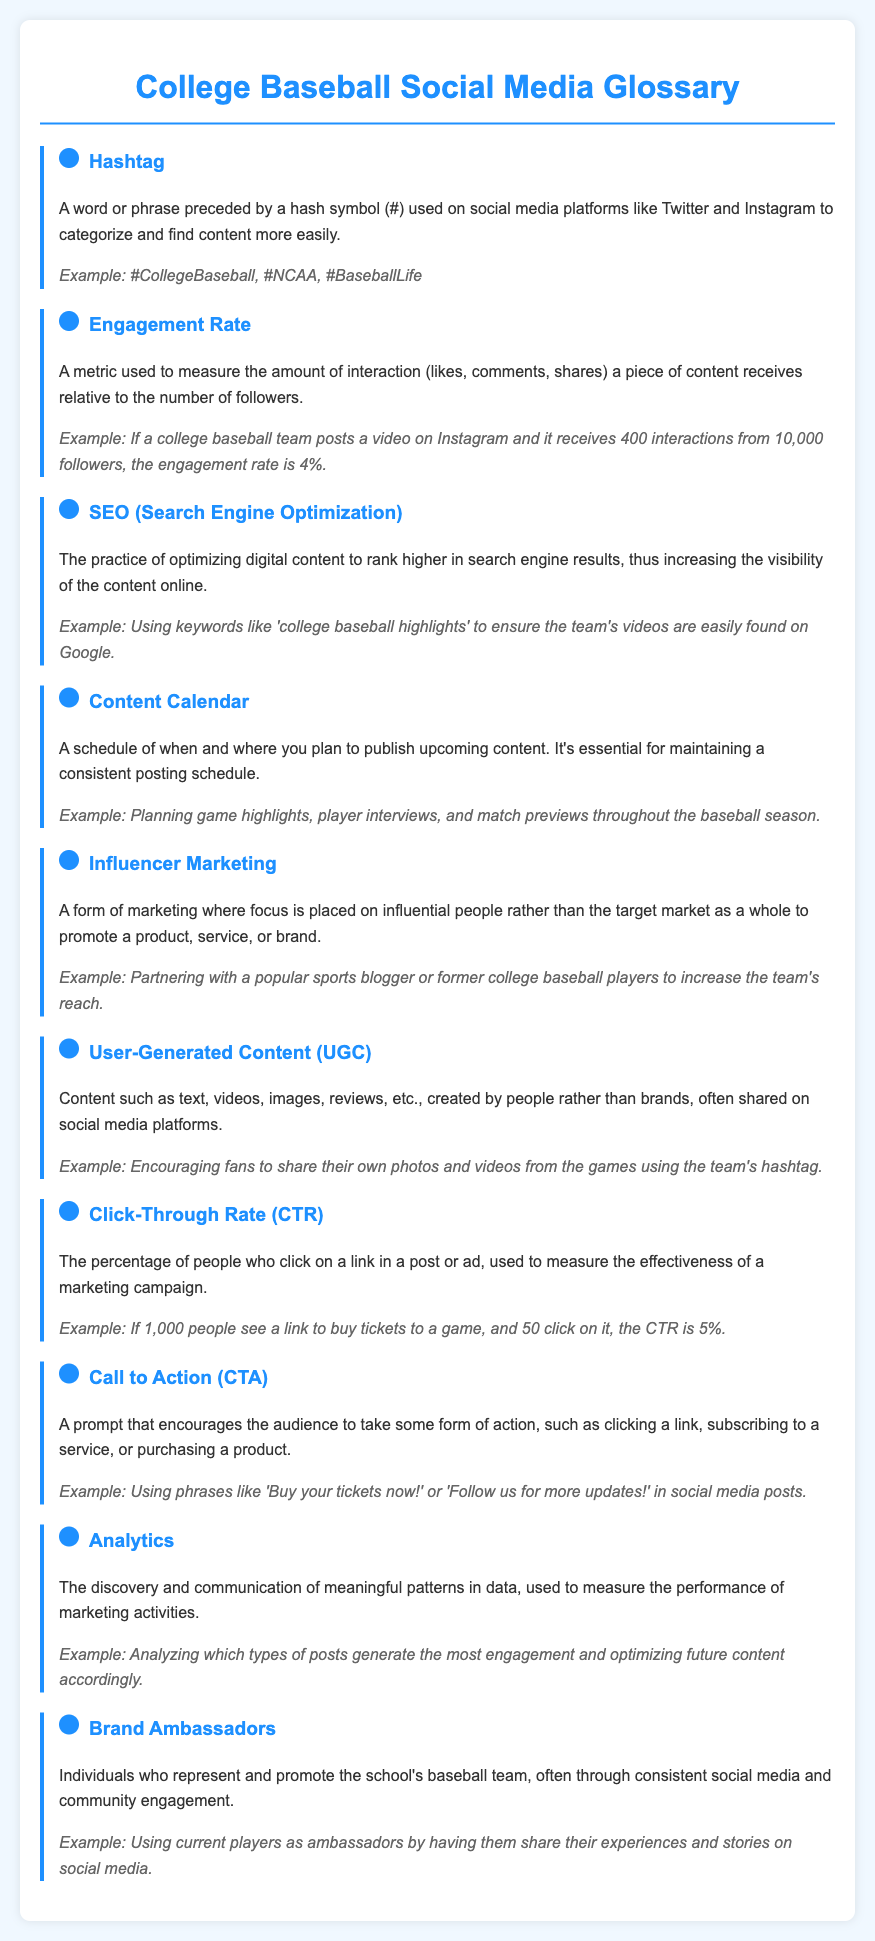What is a hashtag? A hashtag is a word or phrase preceded by a hash symbol used to categorize and find content on social media.
Answer: A word or phrase preceded by a hash symbol What is the engagement rate formula based on the example? The engagement rate is calculated by dividing the number of interactions by the number of followers and multiplying by 100.
Answer: 4% What does SEO stand for? SEO is an acronym used to refer to search engine optimization.
Answer: Search Engine Optimization What type of content is encouraged from fans? Fans are encouraged to share their own photos and videos from the games.
Answer: Their own photos and videos What is the main function of brand ambassadors? Brand ambassadors represent and promote the school's baseball team through engagement.
Answer: Promote the school's baseball team What does UGC stand for? UGC is an acronym that stands for user-generated content.
Answer: User-Generated Content How many glossary items are included? The document contains ten glossary items related to social media and marketing.
Answer: Ten What should a call to action prompt the audience to do? A call to action prompts the audience to take some form of action.
Answer: Take some form of action What is the purpose of an analytics in marketing? The purpose of analytics is to measure the performance of marketing activities through data patterns.
Answer: Measure performance of marketing activities 